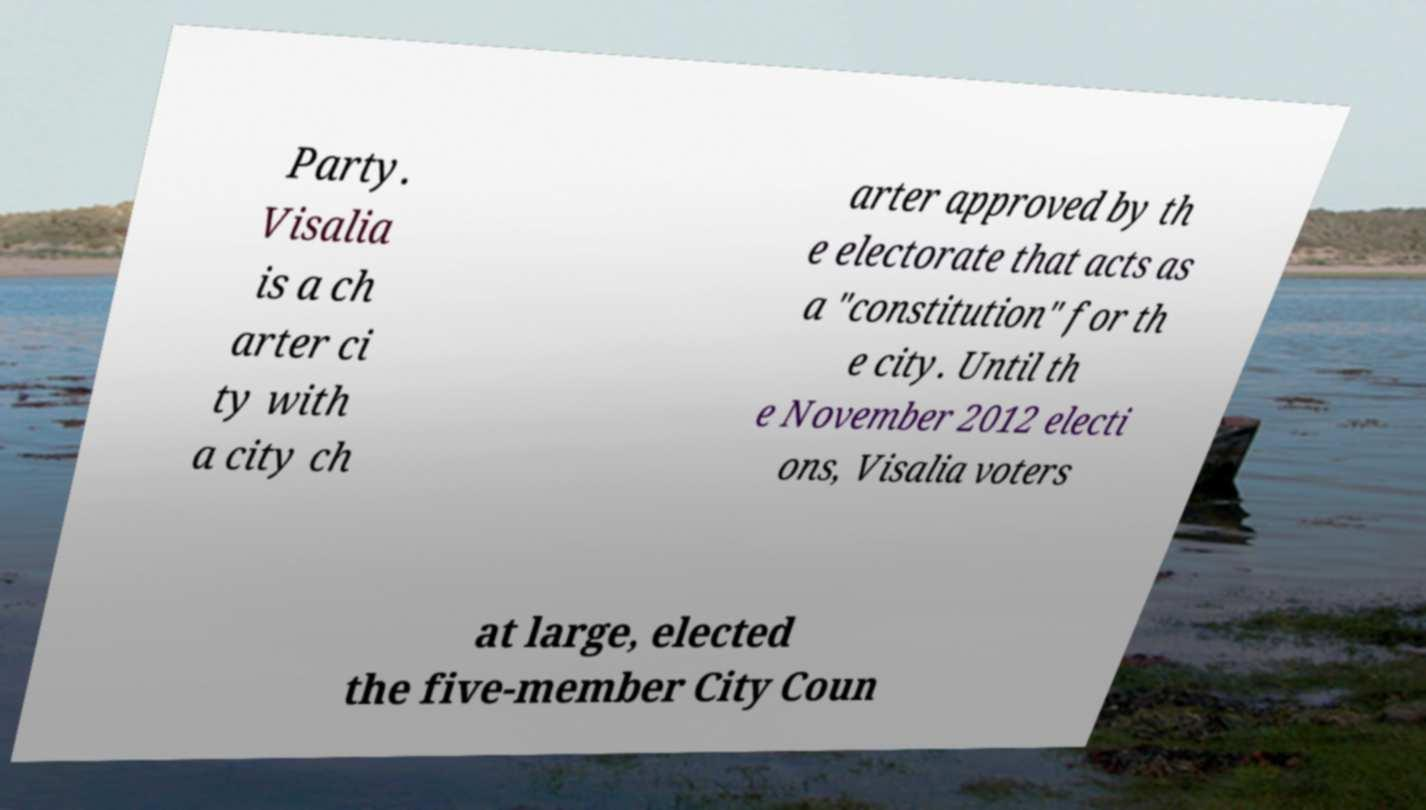Could you extract and type out the text from this image? Party. Visalia is a ch arter ci ty with a city ch arter approved by th e electorate that acts as a "constitution" for th e city. Until th e November 2012 electi ons, Visalia voters at large, elected the five-member City Coun 